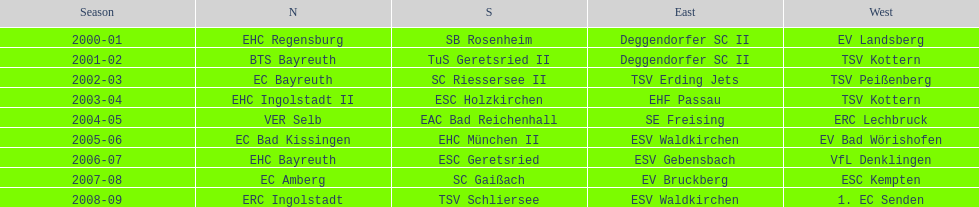Starting with the 2007 - 08 season, does ecs kempten appear in any of the previous years? No. 